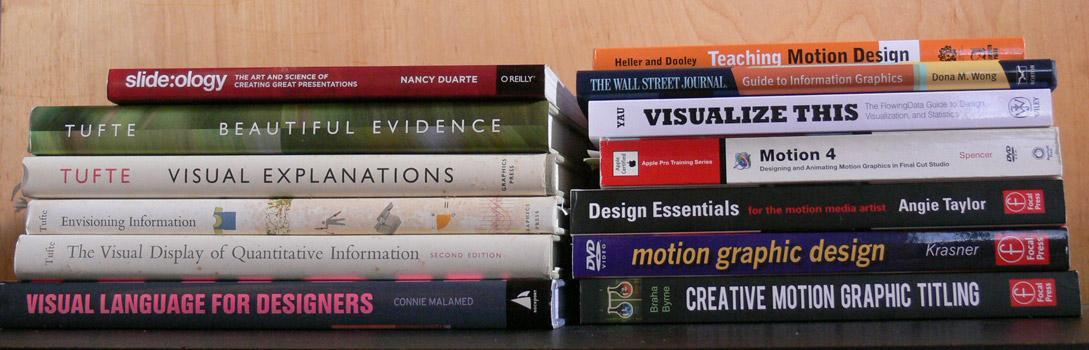What is the name of YAU's book shown?
Answer the question with a short phrase. VISUALIZE THIS Who is the author of Creative motion graphic titling? Braha Byrne How many books by Tufte are shown? 4 How many books are shown? 13 